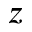Convert formula to latex. <formula><loc_0><loc_0><loc_500><loc_500>z</formula> 